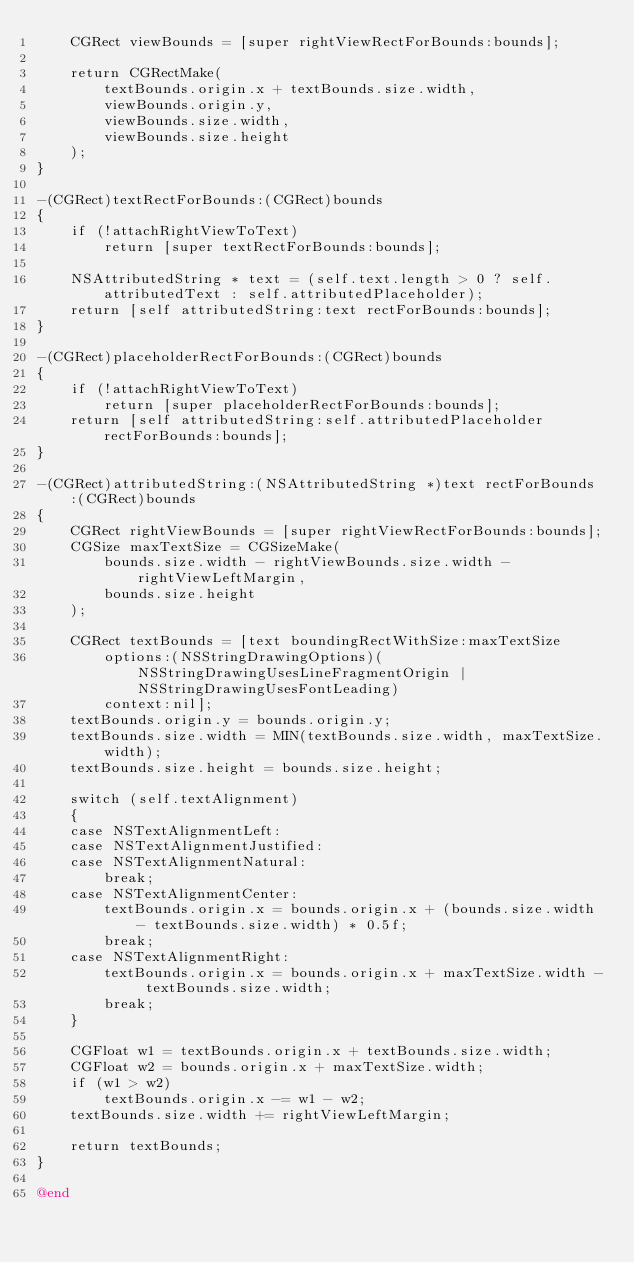Convert code to text. <code><loc_0><loc_0><loc_500><loc_500><_ObjectiveC_>	CGRect viewBounds = [super rightViewRectForBounds:bounds];

	return CGRectMake(
		textBounds.origin.x + textBounds.size.width,
		viewBounds.origin.y,
		viewBounds.size.width,
		viewBounds.size.height
	);
}

-(CGRect)textRectForBounds:(CGRect)bounds
{
	if (!attachRightViewToText)
		return [super textRectForBounds:bounds];

	NSAttributedString * text = (self.text.length > 0 ? self.attributedText : self.attributedPlaceholder);
	return [self attributedString:text rectForBounds:bounds];
}

-(CGRect)placeholderRectForBounds:(CGRect)bounds
{
	if (!attachRightViewToText)
		return [super placeholderRectForBounds:bounds];
	return [self attributedString:self.attributedPlaceholder rectForBounds:bounds];
}

-(CGRect)attributedString:(NSAttributedString *)text rectForBounds:(CGRect)bounds
{
	CGRect rightViewBounds = [super rightViewRectForBounds:bounds];
	CGSize maxTextSize = CGSizeMake(
		bounds.size.width - rightViewBounds.size.width - rightViewLeftMargin,
		bounds.size.height
	);

	CGRect textBounds = [text boundingRectWithSize:maxTextSize
		options:(NSStringDrawingOptions)(NSStringDrawingUsesLineFragmentOrigin | NSStringDrawingUsesFontLeading)
		context:nil];
	textBounds.origin.y = bounds.origin.y;
	textBounds.size.width = MIN(textBounds.size.width, maxTextSize.width);
	textBounds.size.height = bounds.size.height;

	switch (self.textAlignment)
	{
	case NSTextAlignmentLeft:
	case NSTextAlignmentJustified:
	case NSTextAlignmentNatural:
		break;
	case NSTextAlignmentCenter:
		textBounds.origin.x = bounds.origin.x + (bounds.size.width - textBounds.size.width) * 0.5f;
		break;
	case NSTextAlignmentRight:
		textBounds.origin.x = bounds.origin.x + maxTextSize.width - textBounds.size.width;
		break;
	}

	CGFloat w1 = textBounds.origin.x + textBounds.size.width;
	CGFloat w2 = bounds.origin.x + maxTextSize.width;
	if (w1 > w2)
		textBounds.origin.x -= w1 - w2;
	textBounds.size.width += rightViewLeftMargin;

	return textBounds;
}

@end
</code> 